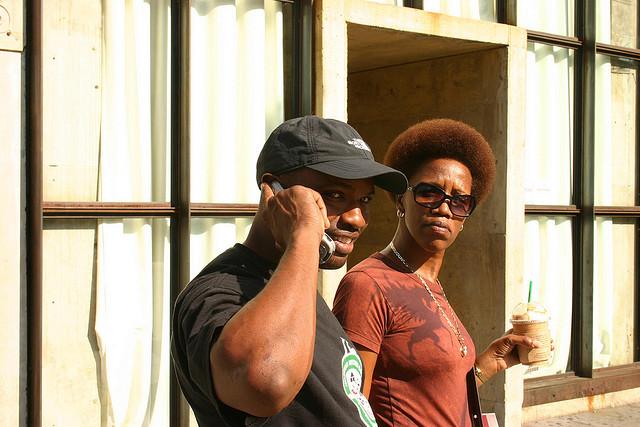Does the woman look happy?
Be succinct. No. Is the man talking on the phone?
Write a very short answer. Yes. What is the woman holding?
Write a very short answer. Drink. 